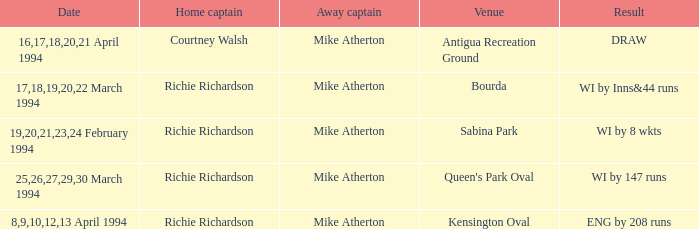Which Home captain has Date of 25,26,27,29,30 march 1994? Richie Richardson. 